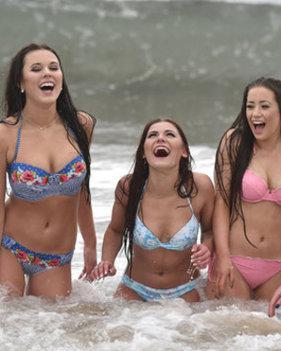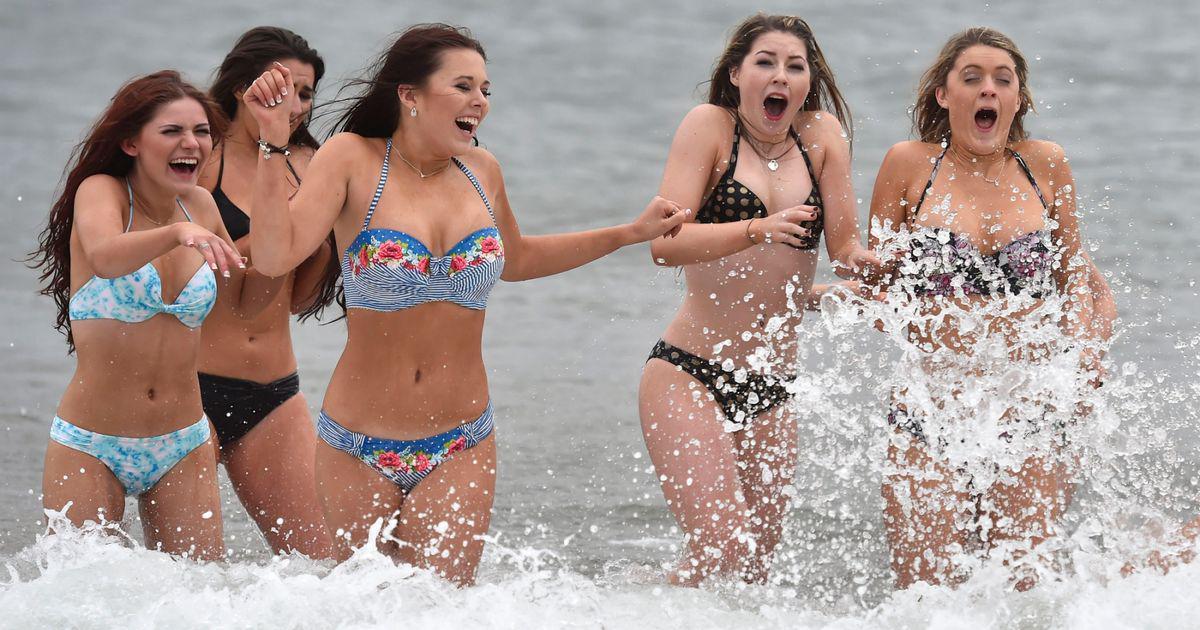The first image is the image on the left, the second image is the image on the right. For the images displayed, is the sentence "At least 2 girls are wearing sunglasses." factually correct? Answer yes or no. No. The first image is the image on the left, the second image is the image on the right. Evaluate the accuracy of this statement regarding the images: "The women in the image on the right are standing at least up to their knees in the water.". Is it true? Answer yes or no. Yes. 